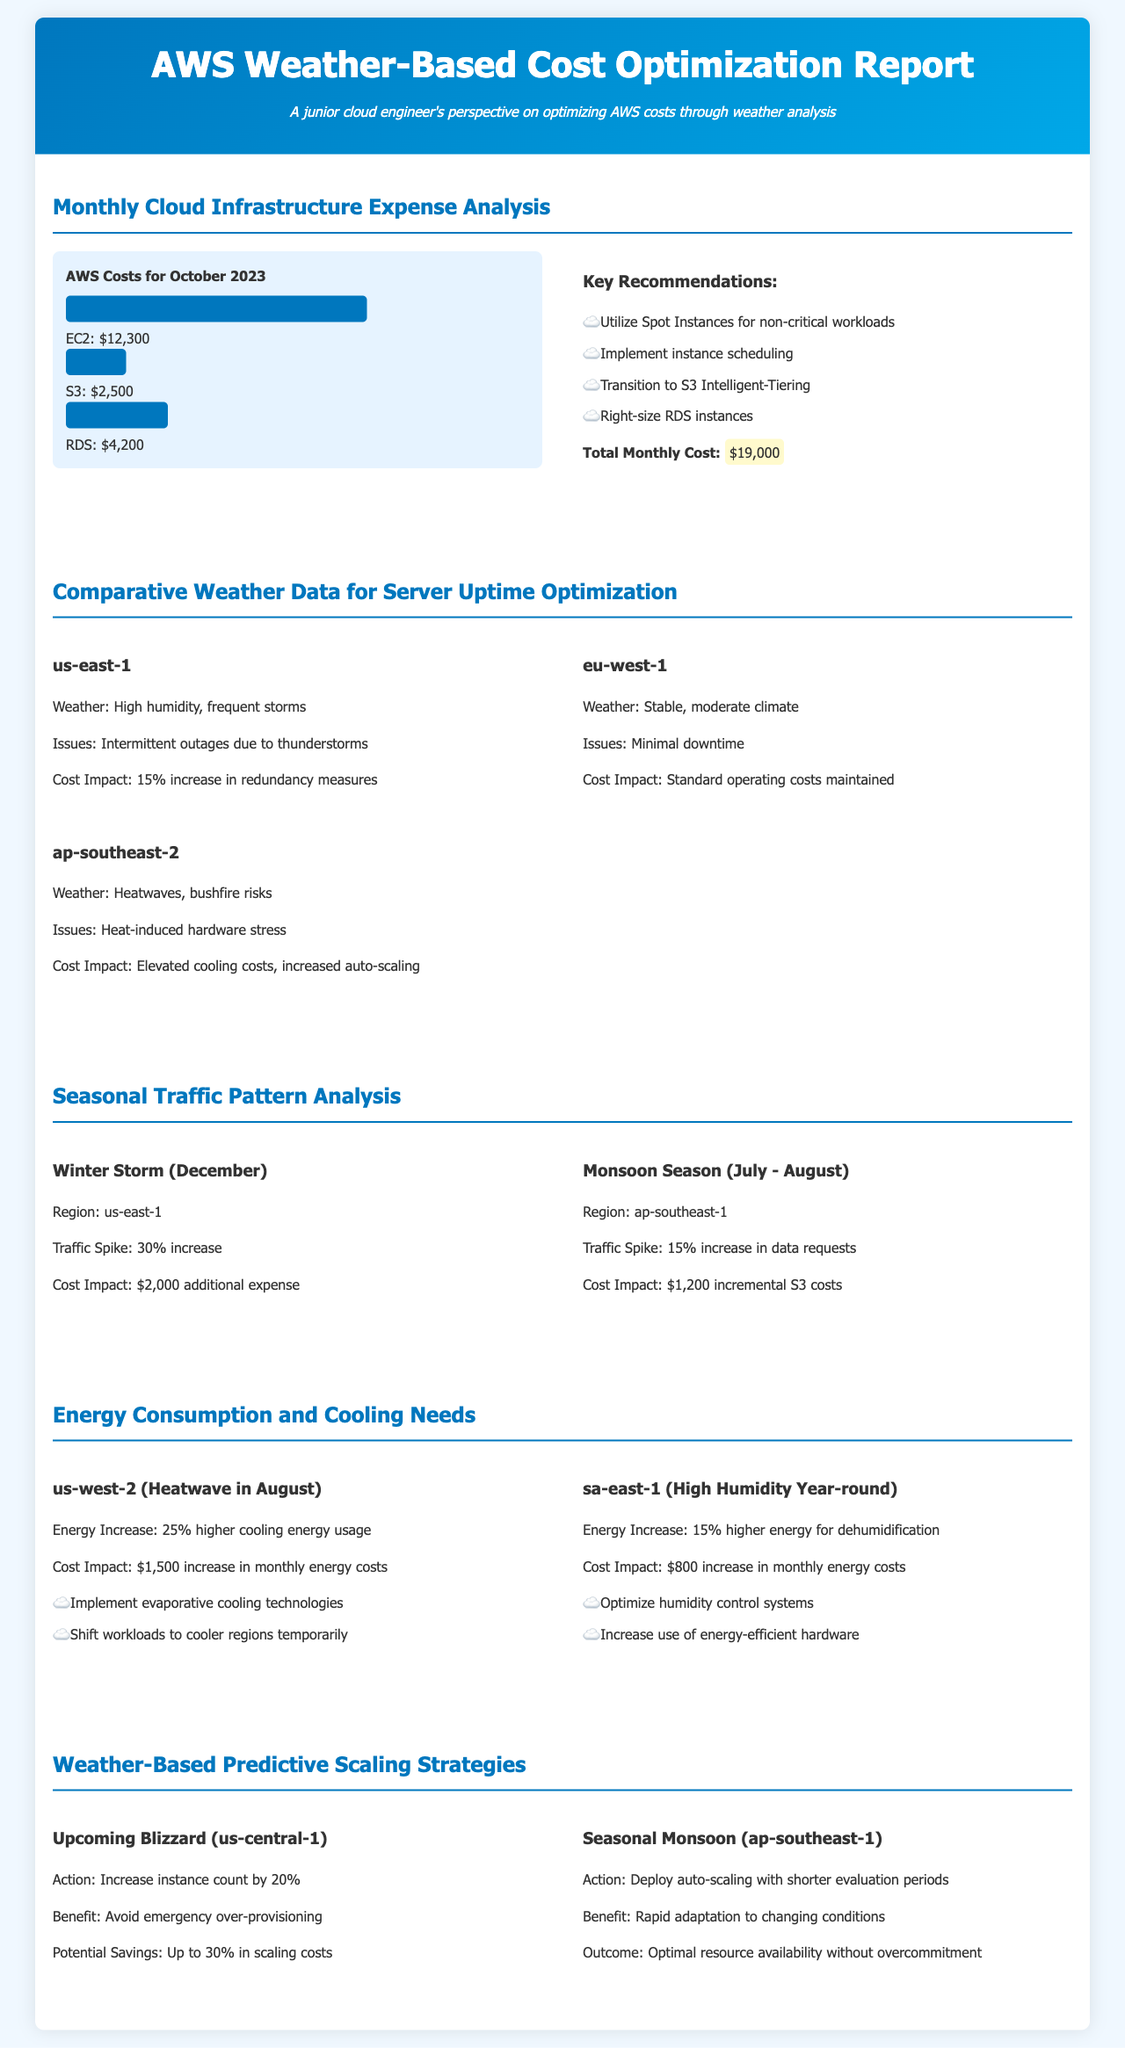What is the total AWS cost for October 2023? The total AWS cost is provided in the document as $19,000.
Answer: $19,000 What is the cost for EC2? The document specifies that the cost for EC2 in October 2023 is $12,300.
Answer: $12,300 Which AWS region had frequent storms? The document notes that us-east-1 experienced high humidity and frequent storms.
Answer: us-east-1 What is one key recommendation for cost optimization? The recommendations include utilizing Spot Instances for non-critical workloads.
Answer: Utilize Spot Instances What was the cost impact of high humidity in sa-east-1? The document indicates an $800 increase in monthly energy costs due to high humidity.
Answer: $800 What action should be taken during an upcoming blizzard in us-central-1? The recommended action is to increase the instance count by 20%.
Answer: Increase instance count by 20% Which weather condition affects server uptime in ap-southeast-2? The document states that heatwaves and bushfire risks affect server uptime in ap-southeast-2.
Answer: Heatwaves, bushfire risks What was the energy cost impact in us-west-2 during the heatwave? The document describes a $1,500 increase in monthly energy costs due to the heatwave.
Answer: $1,500 What traffic spike occurred during the winter storm in December? The document reports a 30% increase in traffic during the winter storm.
Answer: 30% increase 